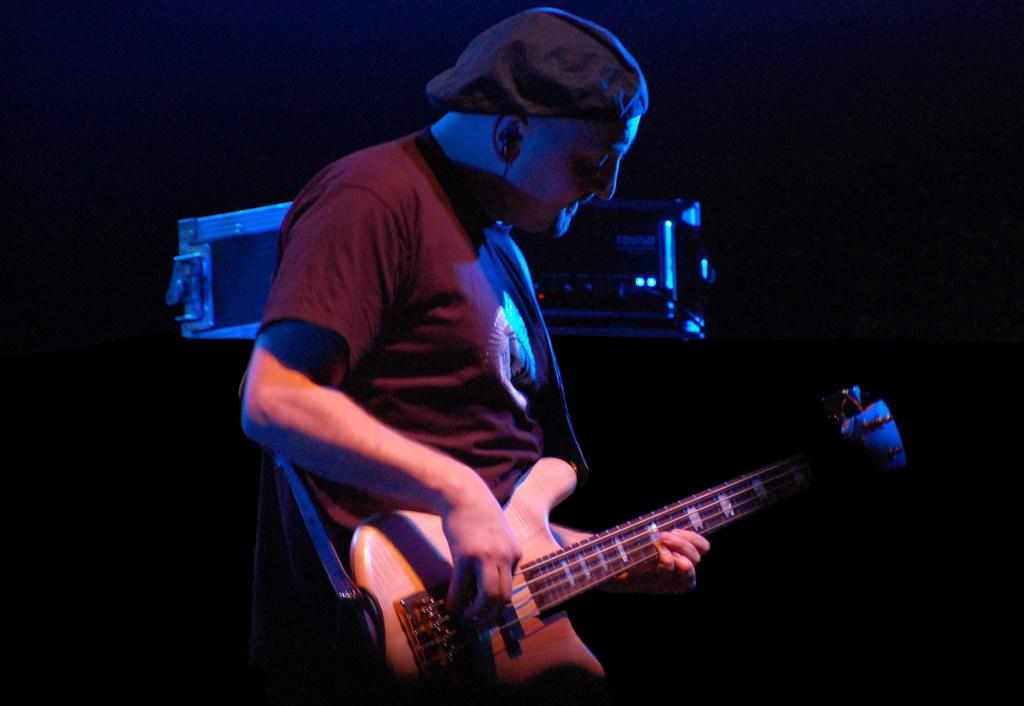Who is the main subject in the image? There is a man in the image. What is the man doing in the image? The man is playing a guitar. Can you identify any other musical instruments in the image? No, there is only one musical instrument visible, which is the guitar. What is the color of the background in the image? The background of the image is dark. What type of bear can be seen interacting with the guitar in the image? There is no bear present in the image, and the guitar is being played by the man. Can you tell me how many cables are connected to the guitar in the image? There is no information about cables in the image; it only shows the man playing the guitar. 